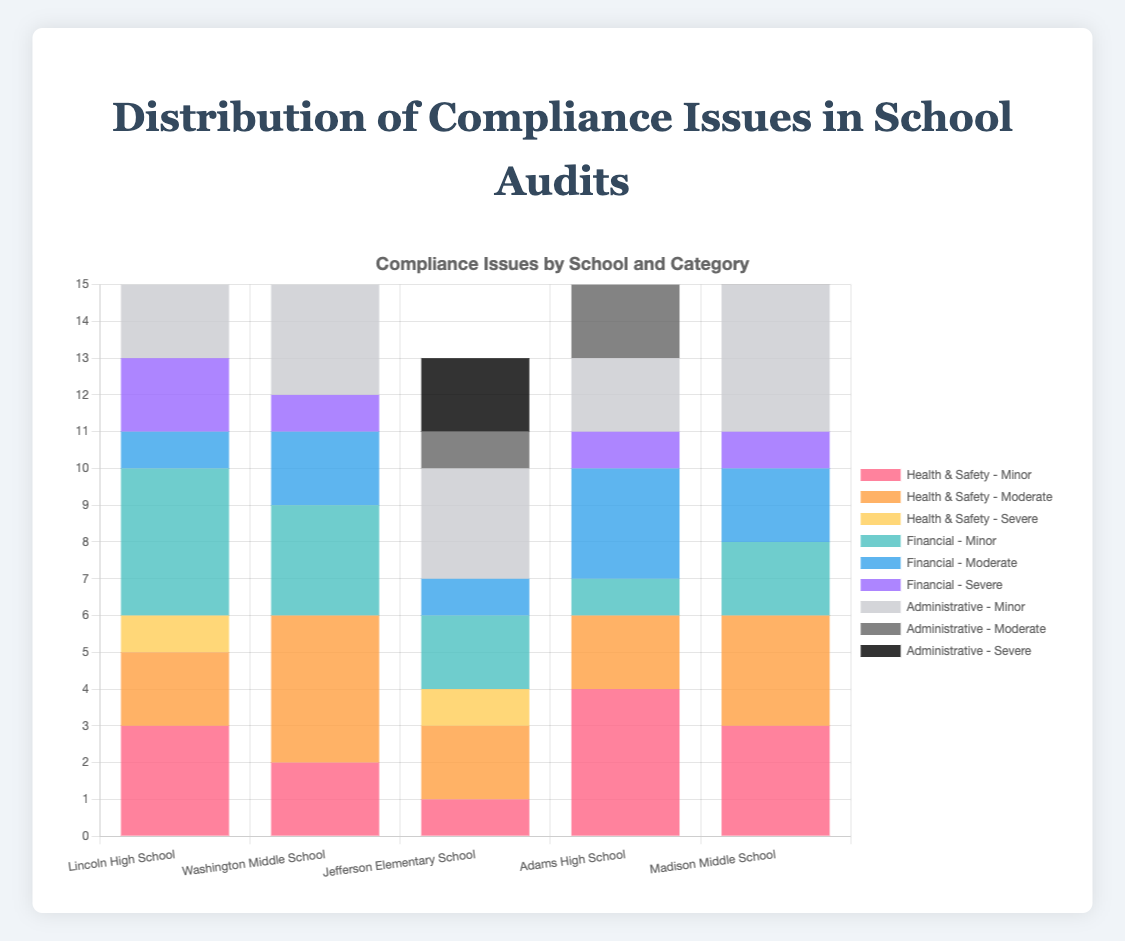Which school has the highest total number of compliance issues across all categories and severity levels? Add up all compliance issues for each school and compare the totals. Lincoln High School: 3+2+1+4+1+2+5+3+0 = 21, Washington Middle School: 2+4+0+3+2+1+4+2+1 = 19, Jefferson Elementary School: 1+2+1+2+1+0+3+1+2 = 13, Adams High School: 4+2+0+1+3+1+2+4+1 = 18, Madison Middle School: 3+3+0+2+2+1+4+1+0 = 16. Lincoln High School has the highest total.
Answer: Lincoln High School Which school has the least severe Health and Safety compliance issues? Compare the count of severe Health and Safety compliance issues across all schools. Lincoln High School: 1, Washington Middle School: 0, Jefferson Elementary School: 1, Adams High School: 0, Madison Middle School: 0. Schools with 0 severe issues are Washington Middle School, Adams High School, and Madison Middle School.
Answer: Washington Middle School, Adams High School, Madison Middle School Which category has the most minor issues at Adams High School? Compare the number of minor issues in Health and Safety, Financial, and Administrative categories at Adams High School: Health and Safety: 4, Financial: 1, Administrative: 2. The Health and Safety category has the most minor issues.
Answer: Health and Safety What is the total number of moderate financial compliance issues found across all schools? Sum the moderate financial compliance issues in all five schools: Lincoln High School: 1, Washington Middle School: 2, Jefferson Elementary School: 1, Adams High School: 3, Madison Middle School: 2. Total is 1+2+1+3+2=9.
Answer: 9 Across all schools, how many more minor administrative issues are there compared to severe administrative issues? Sum the minor administrative issues and severe administrative issues separately, then subtract the latter from the former. Minor administrative issues: Lincoln High School=5, Washington Middle School=4, Jefferson Elementary School=3, Adams High School=2, Madison Middle School=4. Total minor: 5+4+3+2+4=18. Severe administrative issues: Lincoln High School=0, Washington Middle School=1, Jefferson Elementary School=2, Adams High School=1, Madison Middle School=0. Total severe: 0+1+2+1+0=4. Difference: 18-4=14.
Answer: 14 Which school has the tallest bar segment representing severe financial compliance issues in the chart? Compare the height of the bar segments representing severe financial compliance issues for each school. Lincoln High School: 2, Washington Middle School: 1, Jefferson Elementary School: 0, Adams High School: 1, Madison Middle School: 1. The tallest segment is for Lincoln High School with 2 issues.
Answer: Lincoln High School What is the average number of moderate health and safety issues per school? Total number of moderate health and safety issues is (2+4+2+2+3) = 13. Number of schools is 5. Average = 13/5 = 2.6.
Answer: 2.6 Which school has the highest number of total financial compliance issues? Add up minor, moderate, and severe financial compliance issues for each school. Lincoln High School=4+1+2=7, Washington Middle School=3+2+1=6, Jefferson Elementary School=2+1+0=3, Adams High School=1+3+1=5, Madison Middle School=2+2+1=5. Highest total is Lincoln High School with 7 issues.
Answer: Lincoln High School 